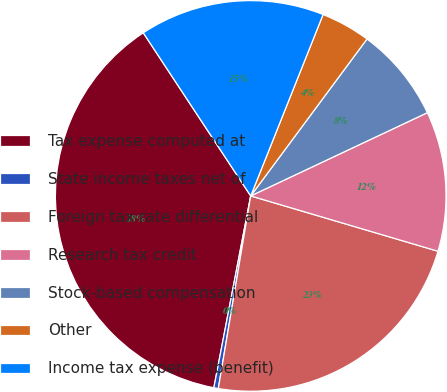Convert chart. <chart><loc_0><loc_0><loc_500><loc_500><pie_chart><fcel>Tax expense computed at<fcel>State income taxes net of<fcel>Foreign tax rate differential<fcel>Research tax credit<fcel>Stock-based compensation<fcel>Other<fcel>Income tax expense (benefit)<nl><fcel>37.71%<fcel>0.37%<fcel>23.08%<fcel>11.58%<fcel>7.84%<fcel>4.11%<fcel>15.31%<nl></chart> 